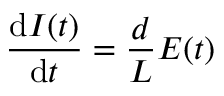<formula> <loc_0><loc_0><loc_500><loc_500>\frac { d I ( t ) } { d t } = \frac { d } { L } E ( t )</formula> 